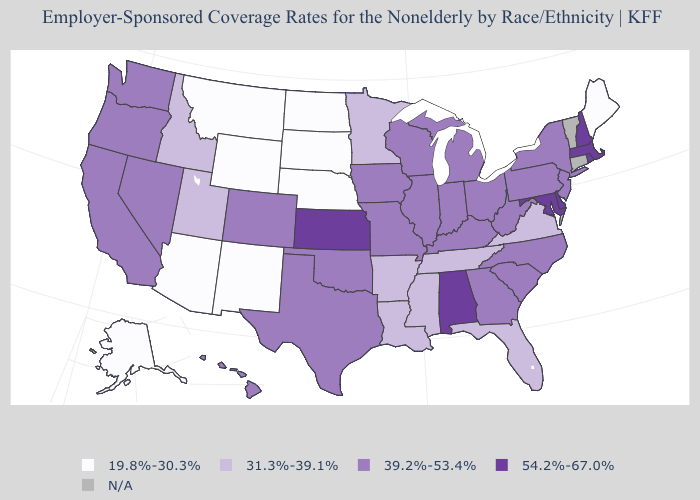What is the highest value in the USA?
Quick response, please. 54.2%-67.0%. What is the value of Michigan?
Give a very brief answer. 39.2%-53.4%. Among the states that border Minnesota , does South Dakota have the highest value?
Keep it brief. No. Name the states that have a value in the range N/A?
Quick response, please. Connecticut, Vermont. Which states hav the highest value in the South?
Quick response, please. Alabama, Delaware, Maryland. What is the value of South Dakota?
Keep it brief. 19.8%-30.3%. What is the value of Georgia?
Be succinct. 39.2%-53.4%. What is the lowest value in states that border New Jersey?
Give a very brief answer. 39.2%-53.4%. Which states hav the highest value in the West?
Write a very short answer. California, Colorado, Hawaii, Nevada, Oregon, Washington. Is the legend a continuous bar?
Keep it brief. No. What is the value of Maine?
Concise answer only. 19.8%-30.3%. What is the value of Utah?
Concise answer only. 31.3%-39.1%. Which states hav the highest value in the West?
Short answer required. California, Colorado, Hawaii, Nevada, Oregon, Washington. What is the value of Oregon?
Answer briefly. 39.2%-53.4%. Does Hawaii have the highest value in the West?
Be succinct. Yes. 